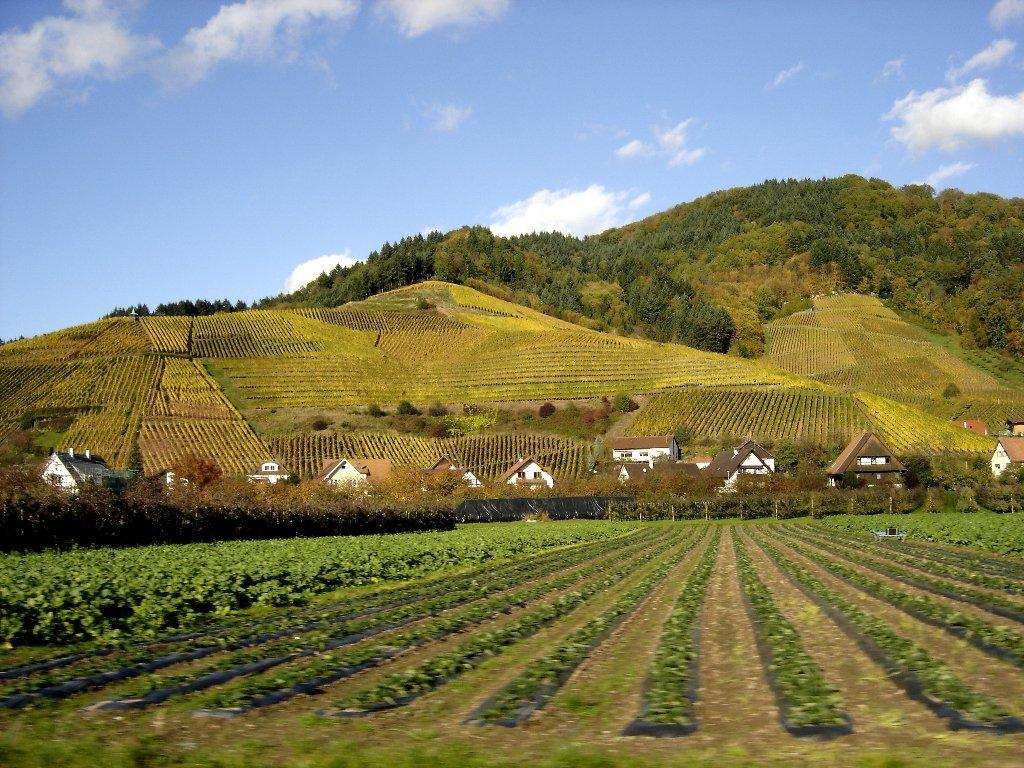What type of vegetation can be seen at the bottom of the image? There are crops at the bottom of the image. What structures are located in the middle of the image? There are houses in the middle of the image. What natural features are visible at the back side of the image? There are hills with trees at the back side of the image. What is visible at the top of the image? The sky is visible at the top of the image. What type of sofa can be seen in the image? There is no sofa present in the image. What type of grain is being harvested in the image? The image does not show any grain being harvested; it only shows crops at the bottom. 